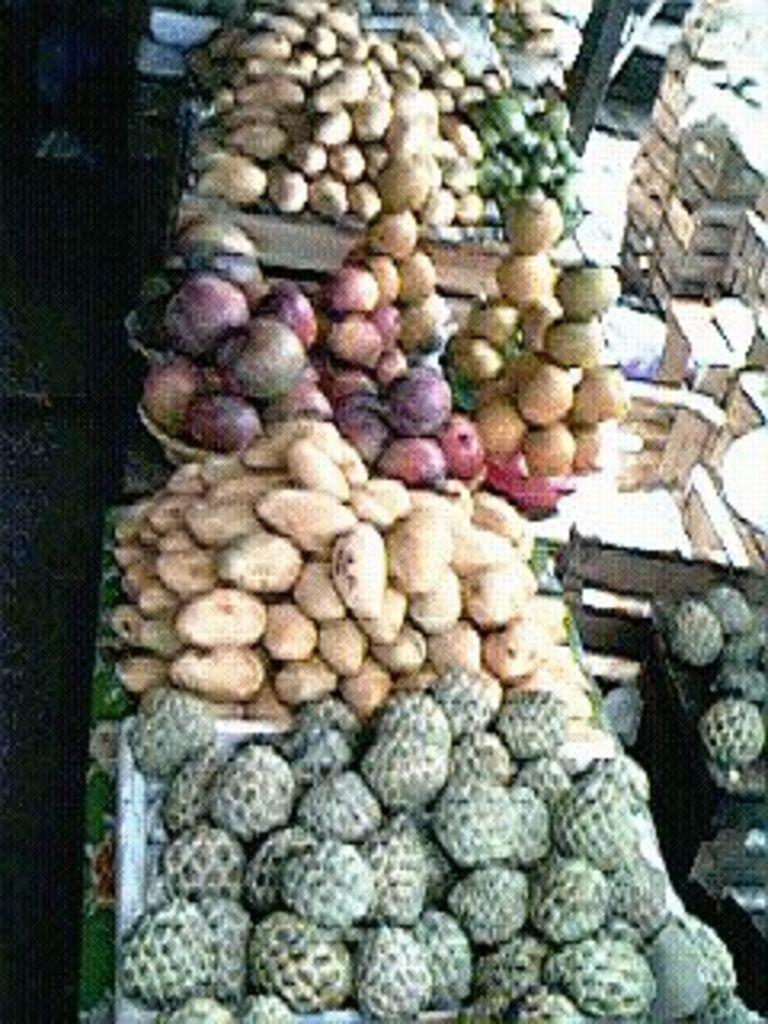What types of food items can be seen in the image? There are fruits and vegetables in the image. Where are the fruits and vegetables located? They are in a stall. Can you describe the variety of vegetables in the image? There are different types of vegetables in the image. What can be seen on the right side of the image? There are boxes on the right side of the image. What position does the paste hold in the image? There is no paste present in the image. 